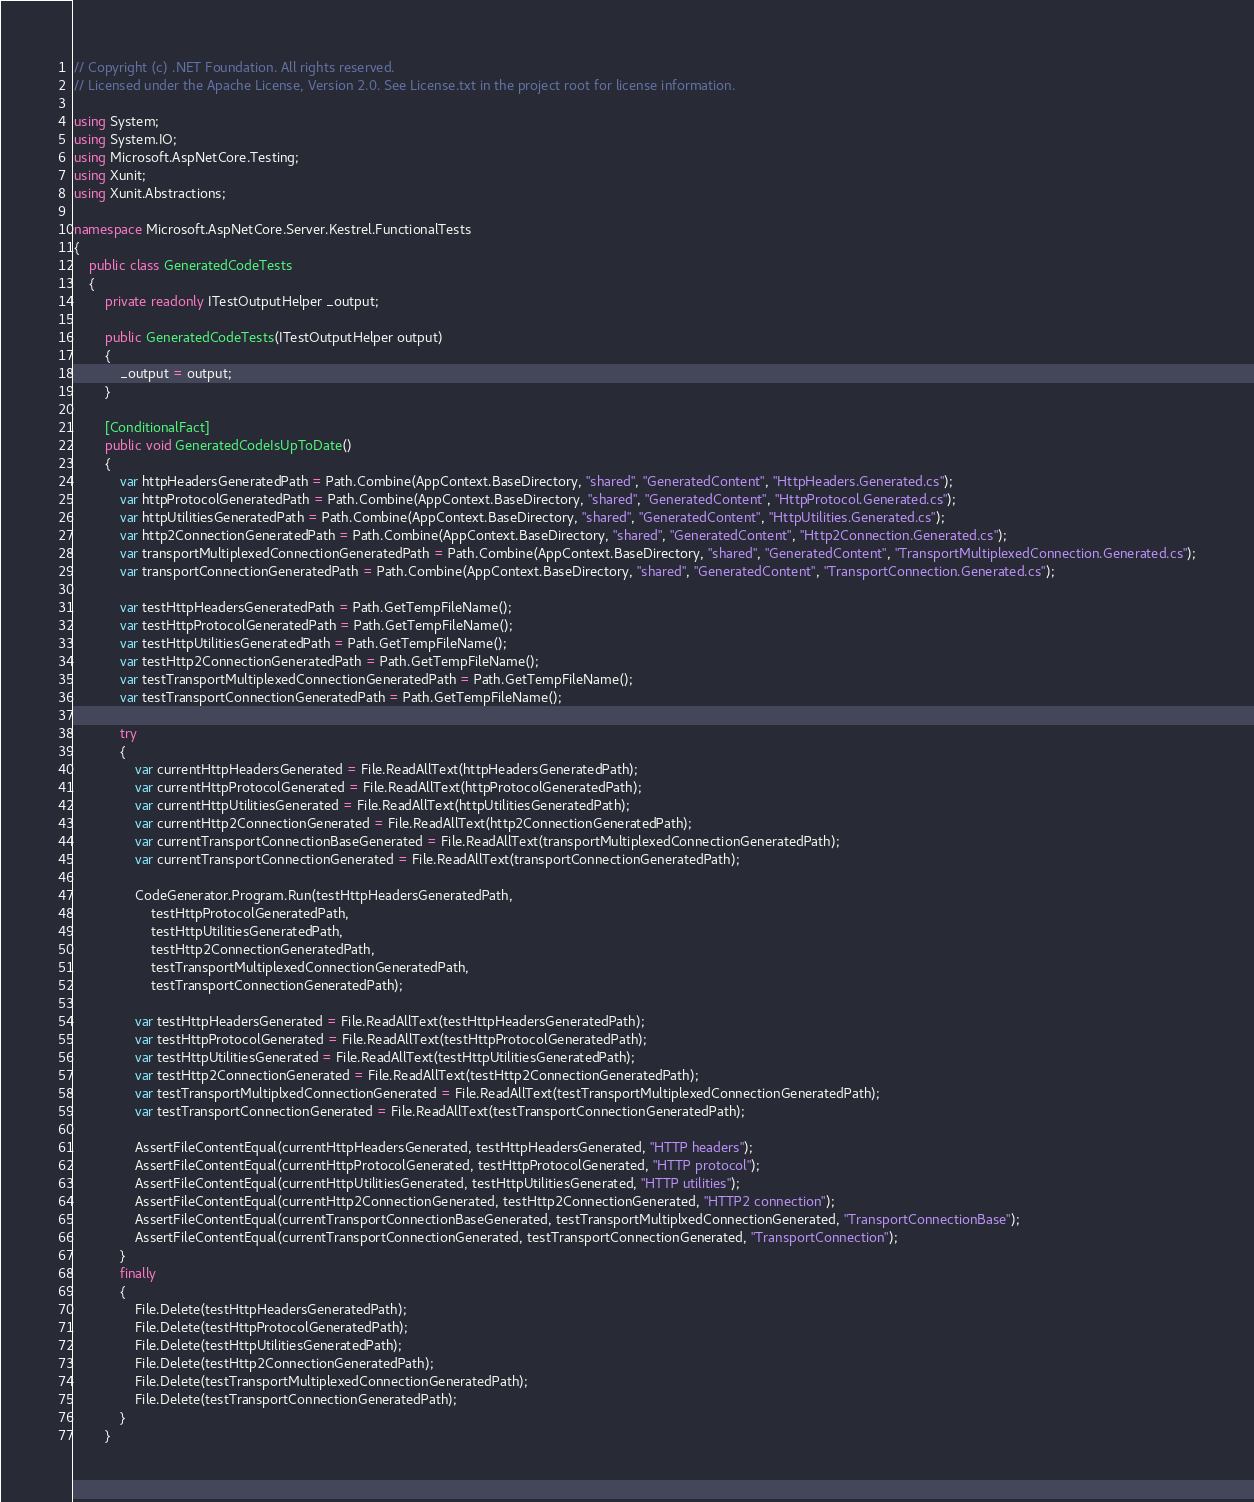<code> <loc_0><loc_0><loc_500><loc_500><_C#_>// Copyright (c) .NET Foundation. All rights reserved.
// Licensed under the Apache License, Version 2.0. See License.txt in the project root for license information.

using System;
using System.IO;
using Microsoft.AspNetCore.Testing;
using Xunit;
using Xunit.Abstractions;

namespace Microsoft.AspNetCore.Server.Kestrel.FunctionalTests
{
    public class GeneratedCodeTests
    {
        private readonly ITestOutputHelper _output;

        public GeneratedCodeTests(ITestOutputHelper output)
        {
            _output = output;
        }

        [ConditionalFact]
        public void GeneratedCodeIsUpToDate()
        {
            var httpHeadersGeneratedPath = Path.Combine(AppContext.BaseDirectory, "shared", "GeneratedContent", "HttpHeaders.Generated.cs");
            var httpProtocolGeneratedPath = Path.Combine(AppContext.BaseDirectory, "shared", "GeneratedContent", "HttpProtocol.Generated.cs");
            var httpUtilitiesGeneratedPath = Path.Combine(AppContext.BaseDirectory, "shared", "GeneratedContent", "HttpUtilities.Generated.cs");
            var http2ConnectionGeneratedPath = Path.Combine(AppContext.BaseDirectory, "shared", "GeneratedContent", "Http2Connection.Generated.cs");
            var transportMultiplexedConnectionGeneratedPath = Path.Combine(AppContext.BaseDirectory, "shared", "GeneratedContent", "TransportMultiplexedConnection.Generated.cs");
            var transportConnectionGeneratedPath = Path.Combine(AppContext.BaseDirectory, "shared", "GeneratedContent", "TransportConnection.Generated.cs");

            var testHttpHeadersGeneratedPath = Path.GetTempFileName();
            var testHttpProtocolGeneratedPath = Path.GetTempFileName();
            var testHttpUtilitiesGeneratedPath = Path.GetTempFileName();
            var testHttp2ConnectionGeneratedPath = Path.GetTempFileName();
            var testTransportMultiplexedConnectionGeneratedPath = Path.GetTempFileName();
            var testTransportConnectionGeneratedPath = Path.GetTempFileName();

            try
            {
                var currentHttpHeadersGenerated = File.ReadAllText(httpHeadersGeneratedPath);
                var currentHttpProtocolGenerated = File.ReadAllText(httpProtocolGeneratedPath);
                var currentHttpUtilitiesGenerated = File.ReadAllText(httpUtilitiesGeneratedPath);
                var currentHttp2ConnectionGenerated = File.ReadAllText(http2ConnectionGeneratedPath);
                var currentTransportConnectionBaseGenerated = File.ReadAllText(transportMultiplexedConnectionGeneratedPath);
                var currentTransportConnectionGenerated = File.ReadAllText(transportConnectionGeneratedPath);

                CodeGenerator.Program.Run(testHttpHeadersGeneratedPath,
                    testHttpProtocolGeneratedPath,
                    testHttpUtilitiesGeneratedPath,
                    testHttp2ConnectionGeneratedPath,
                    testTransportMultiplexedConnectionGeneratedPath,
                    testTransportConnectionGeneratedPath);

                var testHttpHeadersGenerated = File.ReadAllText(testHttpHeadersGeneratedPath);
                var testHttpProtocolGenerated = File.ReadAllText(testHttpProtocolGeneratedPath);
                var testHttpUtilitiesGenerated = File.ReadAllText(testHttpUtilitiesGeneratedPath);
                var testHttp2ConnectionGenerated = File.ReadAllText(testHttp2ConnectionGeneratedPath);
                var testTransportMultiplxedConnectionGenerated = File.ReadAllText(testTransportMultiplexedConnectionGeneratedPath);
                var testTransportConnectionGenerated = File.ReadAllText(testTransportConnectionGeneratedPath);

                AssertFileContentEqual(currentHttpHeadersGenerated, testHttpHeadersGenerated, "HTTP headers");
                AssertFileContentEqual(currentHttpProtocolGenerated, testHttpProtocolGenerated, "HTTP protocol");
                AssertFileContentEqual(currentHttpUtilitiesGenerated, testHttpUtilitiesGenerated, "HTTP utilities");
                AssertFileContentEqual(currentHttp2ConnectionGenerated, testHttp2ConnectionGenerated, "HTTP2 connection");
                AssertFileContentEqual(currentTransportConnectionBaseGenerated, testTransportMultiplxedConnectionGenerated, "TransportConnectionBase");
                AssertFileContentEqual(currentTransportConnectionGenerated, testTransportConnectionGenerated, "TransportConnection");
            }
            finally
            {
                File.Delete(testHttpHeadersGeneratedPath);
                File.Delete(testHttpProtocolGeneratedPath);
                File.Delete(testHttpUtilitiesGeneratedPath);
                File.Delete(testHttp2ConnectionGeneratedPath);
                File.Delete(testTransportMultiplexedConnectionGeneratedPath);
                File.Delete(testTransportConnectionGeneratedPath);
            }
        }
</code> 